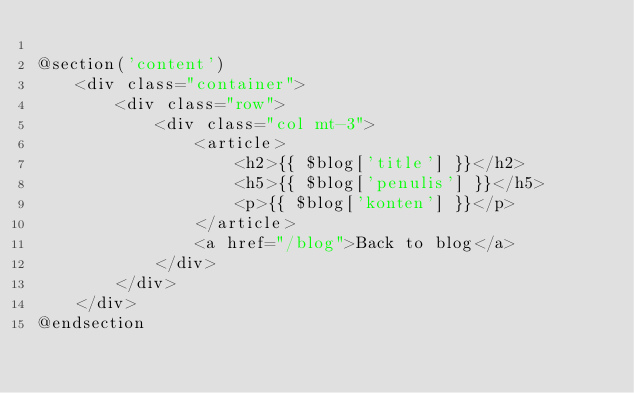<code> <loc_0><loc_0><loc_500><loc_500><_PHP_>
@section('content')
    <div class="container">
        <div class="row">
            <div class="col mt-3">
                <article>
                    <h2>{{ $blog['title'] }}</h2>
                    <h5>{{ $blog['penulis'] }}</h5>
                    <p>{{ $blog['konten'] }}</p>
                </article>
                <a href="/blog">Back to blog</a>
            </div>
        </div>
    </div>
@endsection</code> 